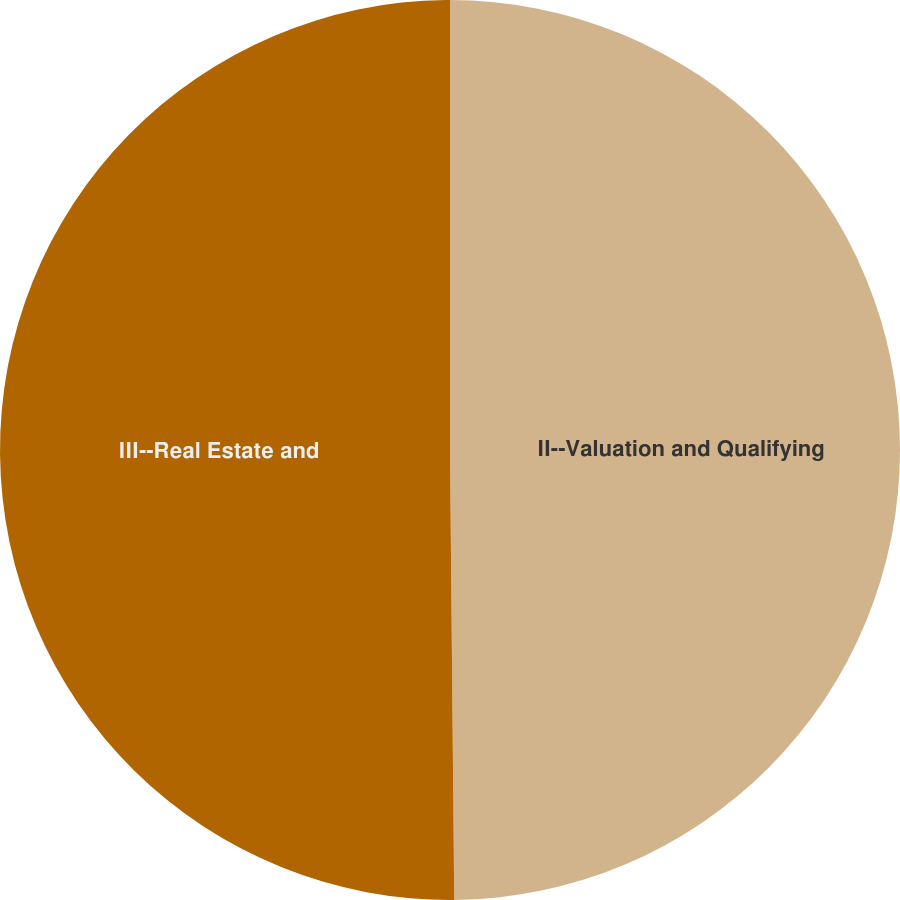<chart> <loc_0><loc_0><loc_500><loc_500><pie_chart><fcel>II--Valuation and Qualifying<fcel>III--Real Estate and<nl><fcel>49.85%<fcel>50.15%<nl></chart> 